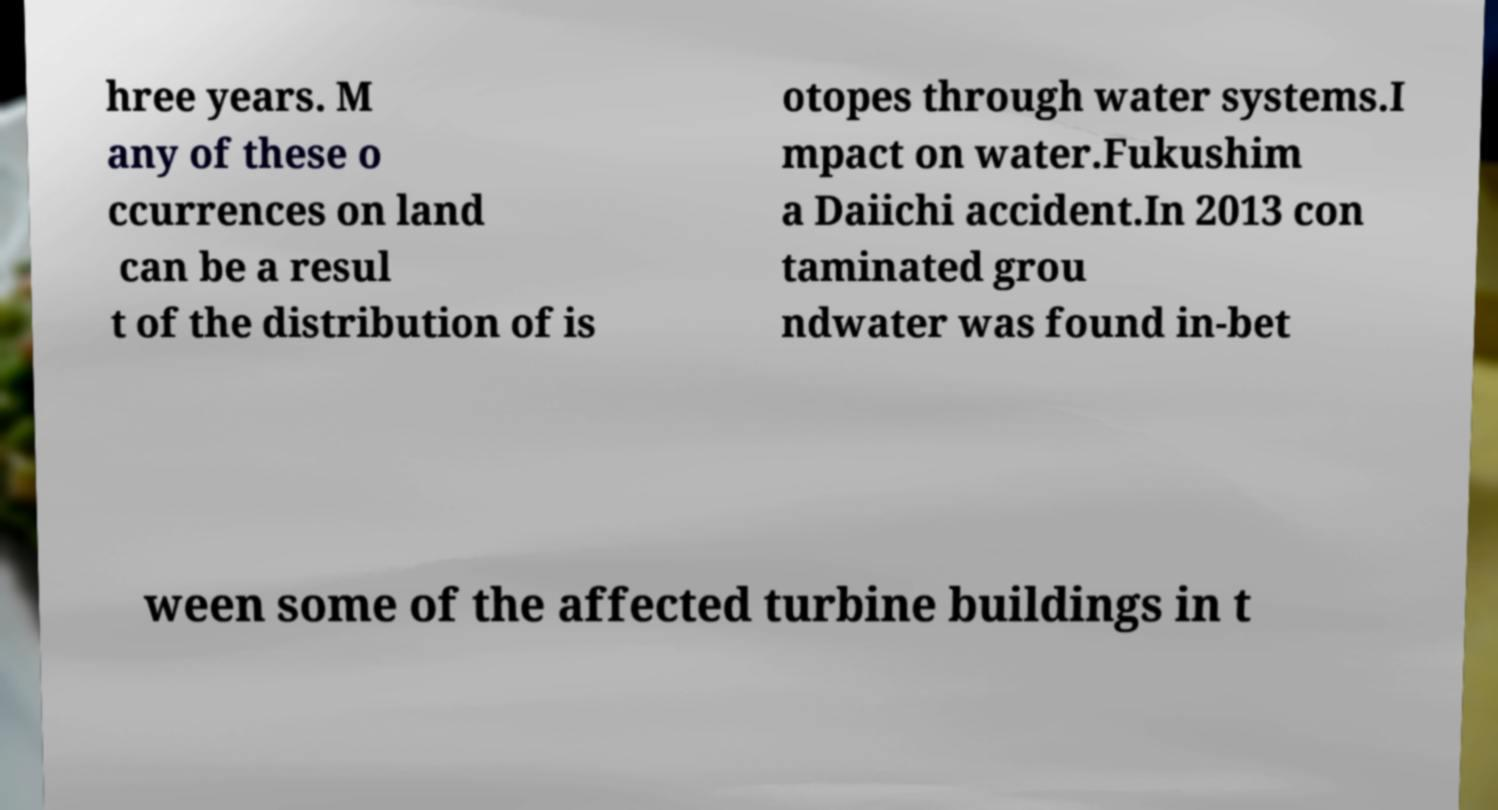Can you accurately transcribe the text from the provided image for me? hree years. M any of these o ccurrences on land can be a resul t of the distribution of is otopes through water systems.I mpact on water.Fukushim a Daiichi accident.In 2013 con taminated grou ndwater was found in-bet ween some of the affected turbine buildings in t 